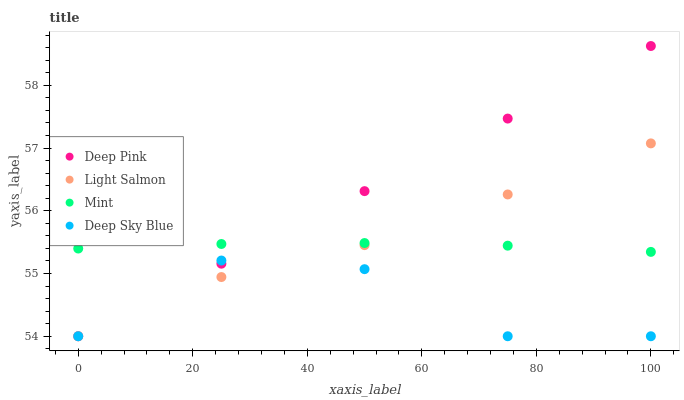Does Deep Sky Blue have the minimum area under the curve?
Answer yes or no. Yes. Does Deep Pink have the maximum area under the curve?
Answer yes or no. Yes. Does Mint have the minimum area under the curve?
Answer yes or no. No. Does Mint have the maximum area under the curve?
Answer yes or no. No. Is Deep Pink the smoothest?
Answer yes or no. Yes. Is Deep Sky Blue the roughest?
Answer yes or no. Yes. Is Mint the smoothest?
Answer yes or no. No. Is Mint the roughest?
Answer yes or no. No. Does Light Salmon have the lowest value?
Answer yes or no. Yes. Does Mint have the lowest value?
Answer yes or no. No. Does Deep Pink have the highest value?
Answer yes or no. Yes. Does Mint have the highest value?
Answer yes or no. No. Is Deep Sky Blue less than Mint?
Answer yes or no. Yes. Is Mint greater than Deep Sky Blue?
Answer yes or no. Yes. Does Deep Sky Blue intersect Light Salmon?
Answer yes or no. Yes. Is Deep Sky Blue less than Light Salmon?
Answer yes or no. No. Is Deep Sky Blue greater than Light Salmon?
Answer yes or no. No. Does Deep Sky Blue intersect Mint?
Answer yes or no. No. 